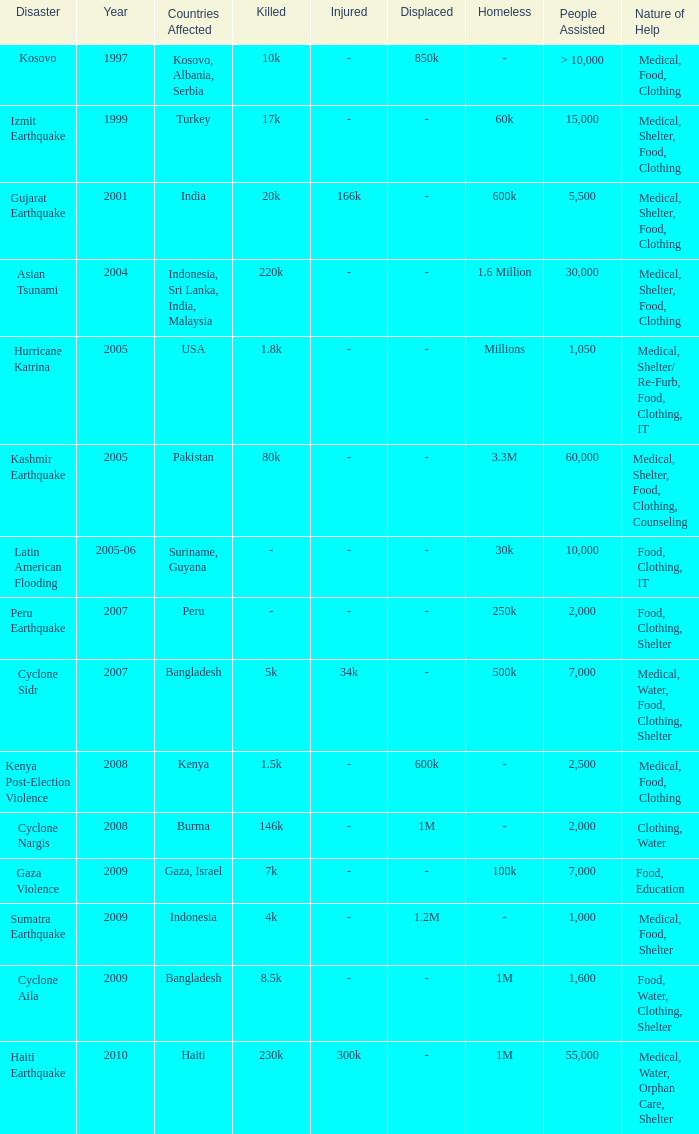In the disaster in which 1,000 people were helped, what was the nature of help? Medical, Food, Shelter. 